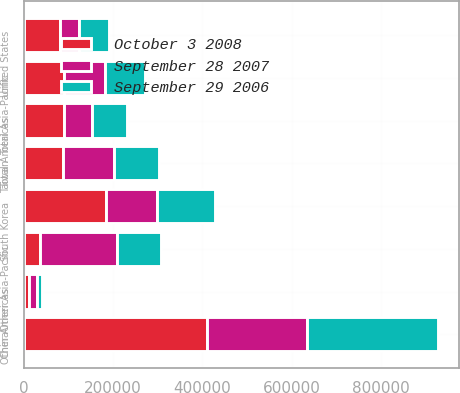Convert chart. <chart><loc_0><loc_0><loc_500><loc_500><stacked_bar_chart><ecel><fcel>United States<fcel>Other Americas<fcel>Total Americas<fcel>China<fcel>South Korea<fcel>Taiwan<fcel>Other Asia-Pacific<fcel>Total Asia-Pacific<nl><fcel>October 3 2008<fcel>79952<fcel>10636<fcel>90588<fcel>410645<fcel>184208<fcel>86544<fcel>36005<fcel>90588<nl><fcel>September 29 2006<fcel>66868<fcel>11230<fcel>78098<fcel>293035<fcel>128253<fcel>101107<fcel>98200<fcel>90588<nl><fcel>September 28 2007<fcel>43180<fcel>18925<fcel>62105<fcel>224539<fcel>114926<fcel>116073<fcel>173523<fcel>90588<nl></chart> 